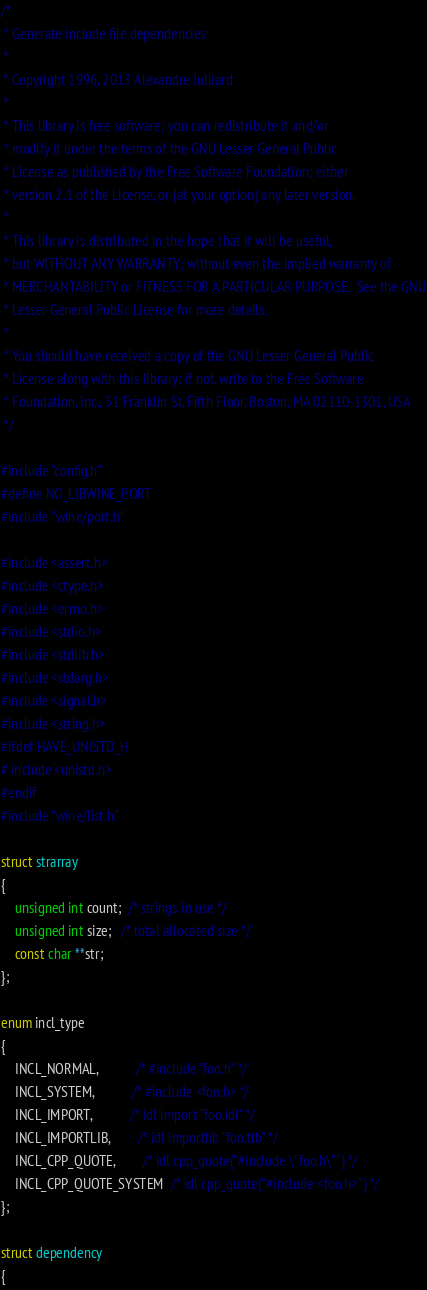<code> <loc_0><loc_0><loc_500><loc_500><_C_>/*
 * Generate include file dependencies
 *
 * Copyright 1996, 2013 Alexandre Julliard
 *
 * This library is free software; you can redistribute it and/or
 * modify it under the terms of the GNU Lesser General Public
 * License as published by the Free Software Foundation; either
 * version 2.1 of the License, or (at your option) any later version.
 *
 * This library is distributed in the hope that it will be useful,
 * but WITHOUT ANY WARRANTY; without even the implied warranty of
 * MERCHANTABILITY or FITNESS FOR A PARTICULAR PURPOSE.  See the GNU
 * Lesser General Public License for more details.
 *
 * You should have received a copy of the GNU Lesser General Public
 * License along with this library; if not, write to the Free Software
 * Foundation, Inc., 51 Franklin St, Fifth Floor, Boston, MA 02110-1301, USA
 */

#include "config.h"
#define NO_LIBWINE_PORT
#include "wine/port.h"

#include <assert.h>
#include <ctype.h>
#include <errno.h>
#include <stdio.h>
#include <stdlib.h>
#include <stdarg.h>
#include <signal.h>
#include <string.h>
#ifdef HAVE_UNISTD_H
# include <unistd.h>
#endif
#include "wine/list.h"

struct strarray
{
    unsigned int count;  /* strings in use */
    unsigned int size;   /* total allocated size */
    const char **str;
};

enum incl_type
{
    INCL_NORMAL,           /* #include "foo.h" */
    INCL_SYSTEM,           /* #include <foo.h> */
    INCL_IMPORT,           /* idl import "foo.idl" */
    INCL_IMPORTLIB,        /* idl importlib "foo.tlb" */
    INCL_CPP_QUOTE,        /* idl cpp_quote("#include \"foo.h\"") */
    INCL_CPP_QUOTE_SYSTEM  /* idl cpp_quote("#include <foo.h>") */
};

struct dependency
{</code> 